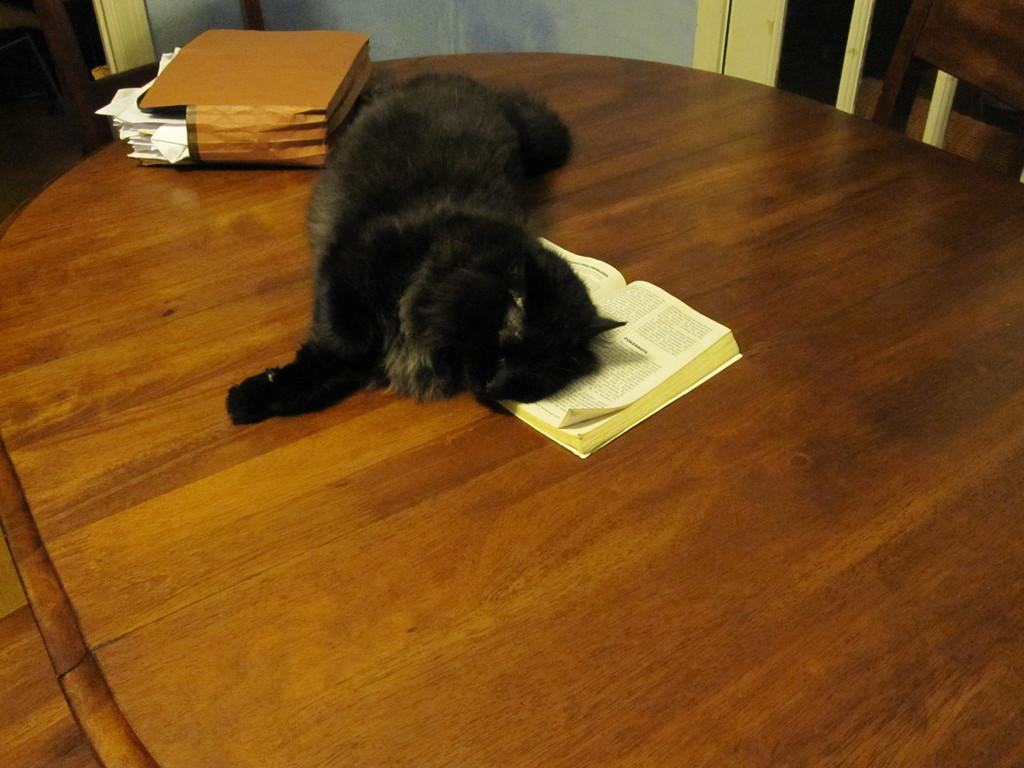What is present on the table in the image? There is a box on the table in the image. What is inside the box on the table? There are papers in the box. Is there any living creature in the image? Yes, there is a black color cat laying in the box. What else can be seen on the table besides the box? There is a book on the table. What type of curtain is hanging near the edge of the table in the image? There is no curtain present in the image, nor is there any reference to an edge of the table. 